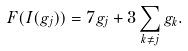<formula> <loc_0><loc_0><loc_500><loc_500>F ( I ( g _ { j } ) ) = 7 g _ { j } + 3 \sum _ { k \neq j } g _ { k } .</formula> 